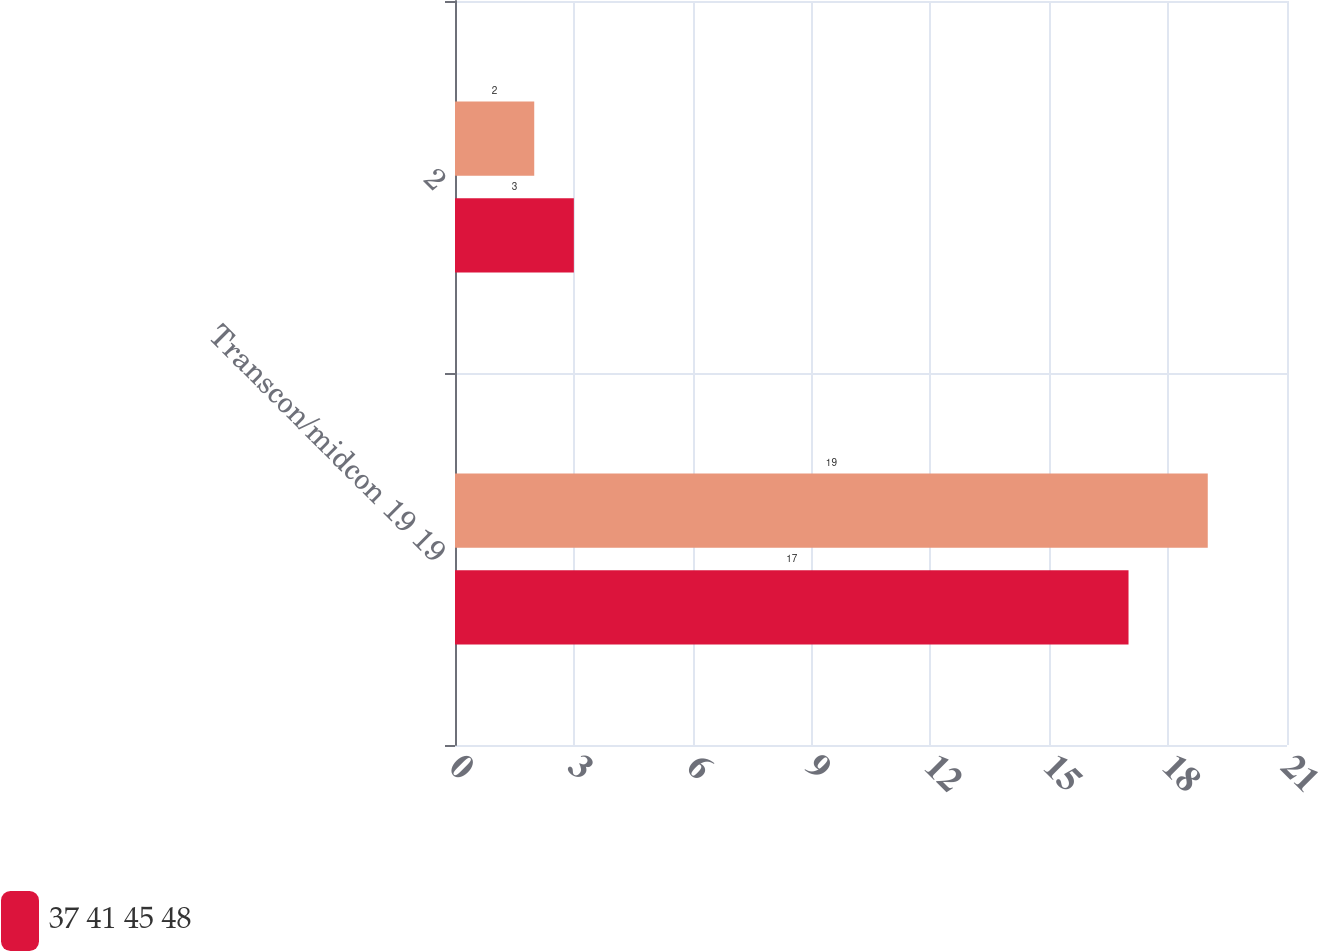Convert chart. <chart><loc_0><loc_0><loc_500><loc_500><stacked_bar_chart><ecel><fcel>Transcon/midcon 19 19<fcel>2<nl><fcel>nan<fcel>19<fcel>2<nl><fcel>37 41 45 48<fcel>17<fcel>3<nl></chart> 